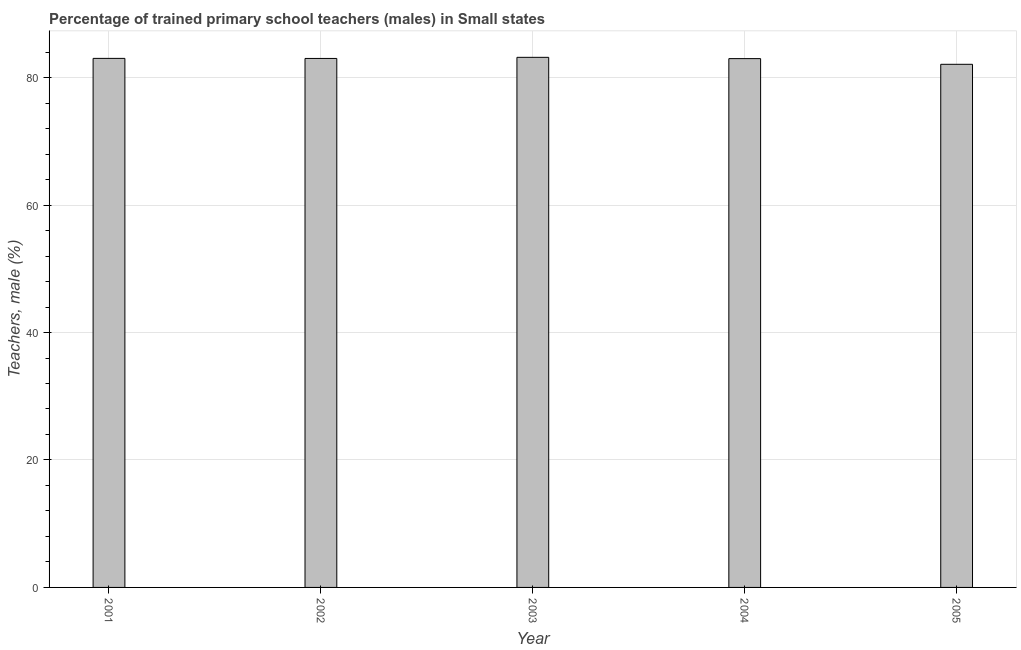Does the graph contain any zero values?
Offer a terse response. No. What is the title of the graph?
Ensure brevity in your answer.  Percentage of trained primary school teachers (males) in Small states. What is the label or title of the Y-axis?
Ensure brevity in your answer.  Teachers, male (%). What is the percentage of trained male teachers in 2001?
Offer a terse response. 83.01. Across all years, what is the maximum percentage of trained male teachers?
Ensure brevity in your answer.  83.18. Across all years, what is the minimum percentage of trained male teachers?
Offer a terse response. 82.08. In which year was the percentage of trained male teachers minimum?
Provide a succinct answer. 2005. What is the sum of the percentage of trained male teachers?
Ensure brevity in your answer.  414.26. What is the difference between the percentage of trained male teachers in 2001 and 2003?
Provide a short and direct response. -0.17. What is the average percentage of trained male teachers per year?
Ensure brevity in your answer.  82.85. What is the median percentage of trained male teachers?
Your answer should be very brief. 83. In how many years, is the percentage of trained male teachers greater than 56 %?
Your answer should be compact. 5. Do a majority of the years between 2003 and 2001 (inclusive) have percentage of trained male teachers greater than 8 %?
Your response must be concise. Yes. Is the difference between the percentage of trained male teachers in 2002 and 2004 greater than the difference between any two years?
Your response must be concise. No. What is the difference between the highest and the second highest percentage of trained male teachers?
Provide a short and direct response. 0.17. What is the difference between the highest and the lowest percentage of trained male teachers?
Provide a short and direct response. 1.09. How many bars are there?
Offer a very short reply. 5. Are all the bars in the graph horizontal?
Give a very brief answer. No. How many years are there in the graph?
Keep it short and to the point. 5. What is the Teachers, male (%) in 2001?
Give a very brief answer. 83.01. What is the Teachers, male (%) in 2002?
Make the answer very short. 83. What is the Teachers, male (%) of 2003?
Give a very brief answer. 83.18. What is the Teachers, male (%) of 2004?
Provide a succinct answer. 82.98. What is the Teachers, male (%) in 2005?
Your answer should be compact. 82.08. What is the difference between the Teachers, male (%) in 2001 and 2002?
Your answer should be compact. 0.01. What is the difference between the Teachers, male (%) in 2001 and 2003?
Offer a terse response. -0.17. What is the difference between the Teachers, male (%) in 2001 and 2004?
Offer a very short reply. 0.04. What is the difference between the Teachers, male (%) in 2001 and 2005?
Your response must be concise. 0.93. What is the difference between the Teachers, male (%) in 2002 and 2003?
Ensure brevity in your answer.  -0.17. What is the difference between the Teachers, male (%) in 2002 and 2004?
Make the answer very short. 0.03. What is the difference between the Teachers, male (%) in 2002 and 2005?
Offer a terse response. 0.92. What is the difference between the Teachers, male (%) in 2003 and 2004?
Your answer should be compact. 0.2. What is the difference between the Teachers, male (%) in 2003 and 2005?
Your response must be concise. 1.09. What is the difference between the Teachers, male (%) in 2004 and 2005?
Offer a very short reply. 0.89. What is the ratio of the Teachers, male (%) in 2001 to that in 2002?
Your response must be concise. 1. What is the ratio of the Teachers, male (%) in 2001 to that in 2003?
Your response must be concise. 1. What is the ratio of the Teachers, male (%) in 2002 to that in 2003?
Provide a short and direct response. 1. What is the ratio of the Teachers, male (%) in 2002 to that in 2004?
Offer a very short reply. 1. What is the ratio of the Teachers, male (%) in 2003 to that in 2005?
Provide a succinct answer. 1.01. What is the ratio of the Teachers, male (%) in 2004 to that in 2005?
Provide a short and direct response. 1.01. 